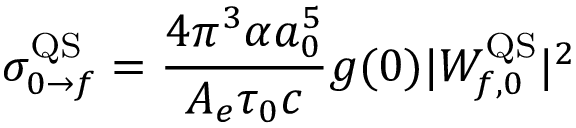<formula> <loc_0><loc_0><loc_500><loc_500>\sigma _ { 0 \rightarrow f } ^ { Q S } = \frac { 4 \pi ^ { 3 } \alpha a _ { 0 } ^ { 5 } } { A _ { e } \tau _ { 0 } c } g ( 0 ) | W _ { f , 0 } ^ { Q S } | ^ { 2 }</formula> 